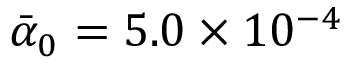Convert formula to latex. <formula><loc_0><loc_0><loc_500><loc_500>\bar { \alpha } _ { 0 } = 5 . 0 \times 1 0 ^ { - 4 }</formula> 